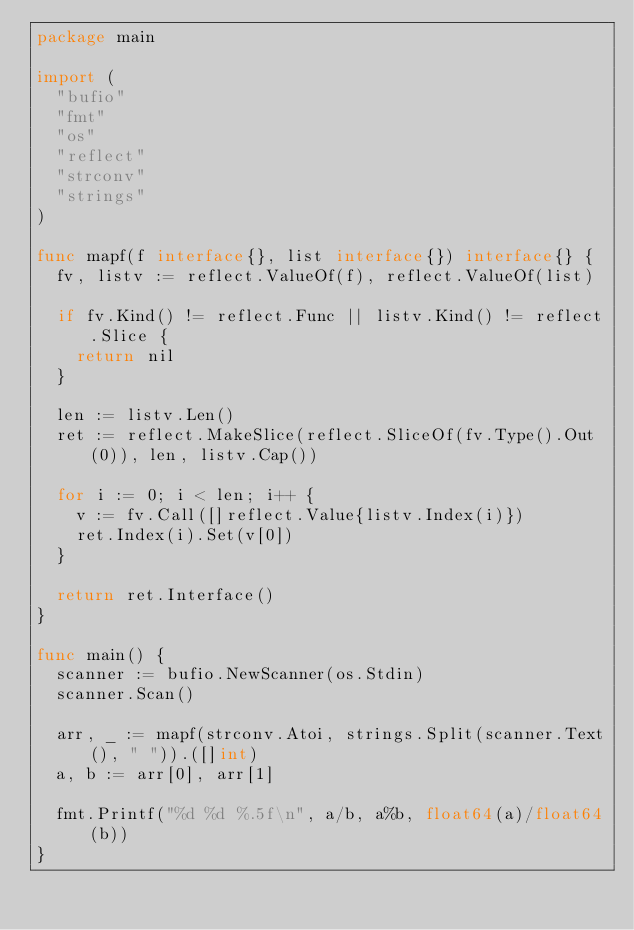Convert code to text. <code><loc_0><loc_0><loc_500><loc_500><_Go_>package main

import (
	"bufio"
	"fmt"
	"os"
	"reflect"
	"strconv"
	"strings"
)

func mapf(f interface{}, list interface{}) interface{} {
	fv, listv := reflect.ValueOf(f), reflect.ValueOf(list)

	if fv.Kind() != reflect.Func || listv.Kind() != reflect.Slice {
		return nil
	}

	len := listv.Len()
	ret := reflect.MakeSlice(reflect.SliceOf(fv.Type().Out(0)), len, listv.Cap())

	for i := 0; i < len; i++ {
		v := fv.Call([]reflect.Value{listv.Index(i)})
		ret.Index(i).Set(v[0])
	}

	return ret.Interface()
}

func main() {
	scanner := bufio.NewScanner(os.Stdin)
	scanner.Scan()

	arr, _ := mapf(strconv.Atoi, strings.Split(scanner.Text(), " ")).([]int)
	a, b := arr[0], arr[1]

	fmt.Printf("%d %d %.5f\n", a/b, a%b, float64(a)/float64(b))
}

</code> 